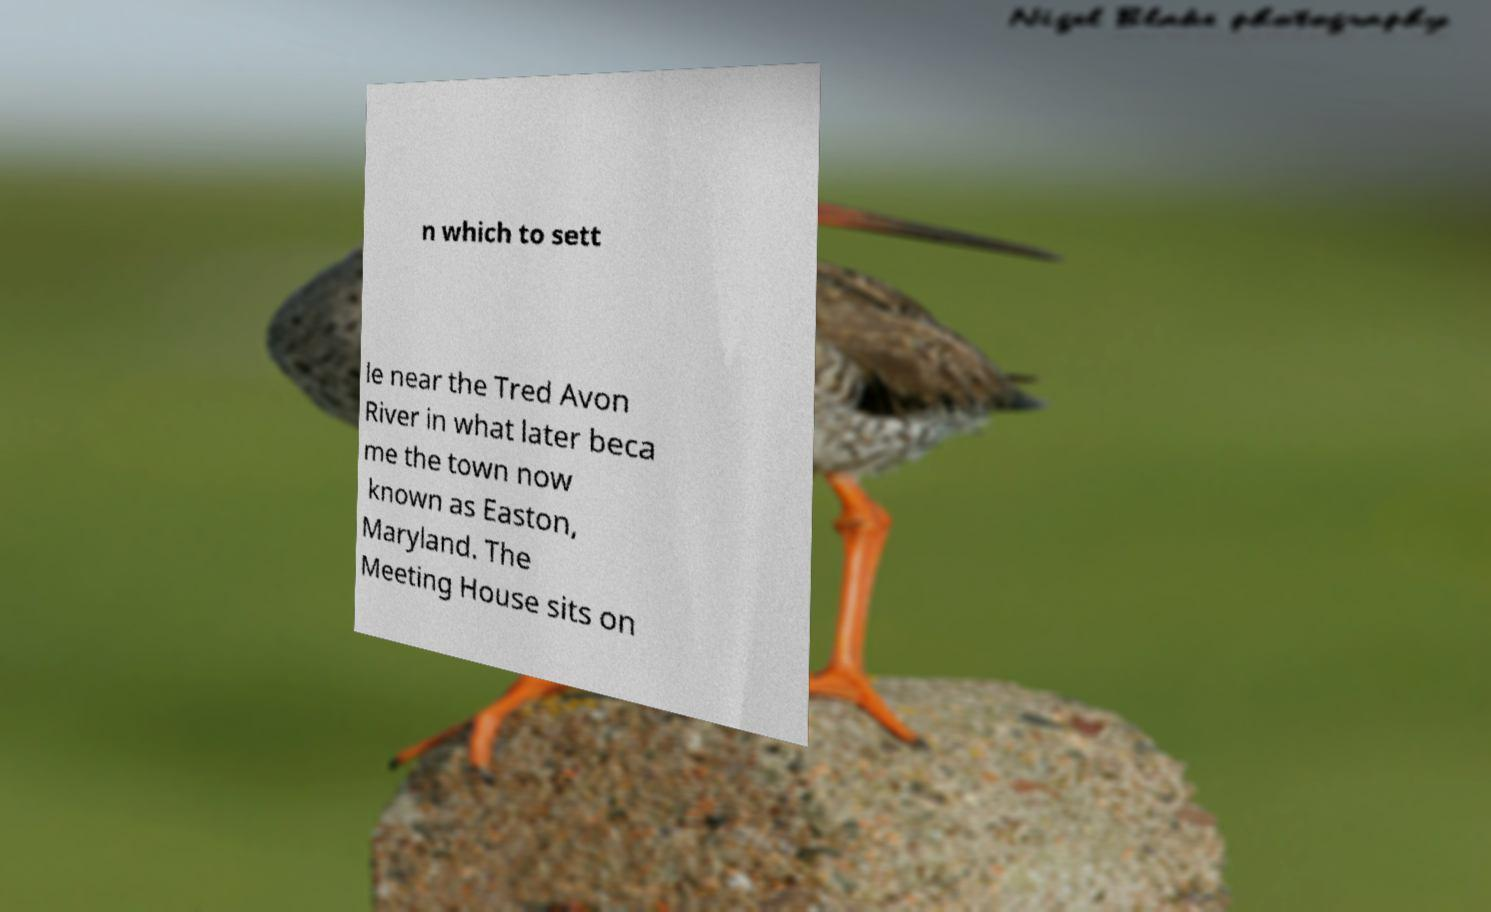Please identify and transcribe the text found in this image. n which to sett le near the Tred Avon River in what later beca me the town now known as Easton, Maryland. The Meeting House sits on 